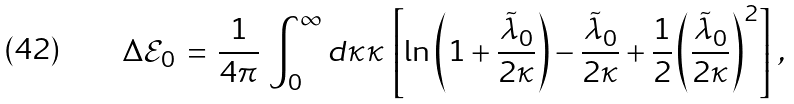Convert formula to latex. <formula><loc_0><loc_0><loc_500><loc_500>\Delta { \mathcal { E } } _ { 0 } \, = \, \frac { 1 } { 4 \pi } \, \int _ { 0 } ^ { \infty } d \kappa \kappa \, \left [ \ln \left ( 1 + \frac { \tilde { \lambda } _ { 0 } } { 2 \kappa } \right ) - \frac { \tilde { \lambda } _ { 0 } } { 2 \kappa } + \frac { 1 } { 2 } \left ( \frac { \tilde { \lambda } _ { 0 } } { 2 \kappa } \right ) ^ { 2 } \right ] \, ,</formula> 